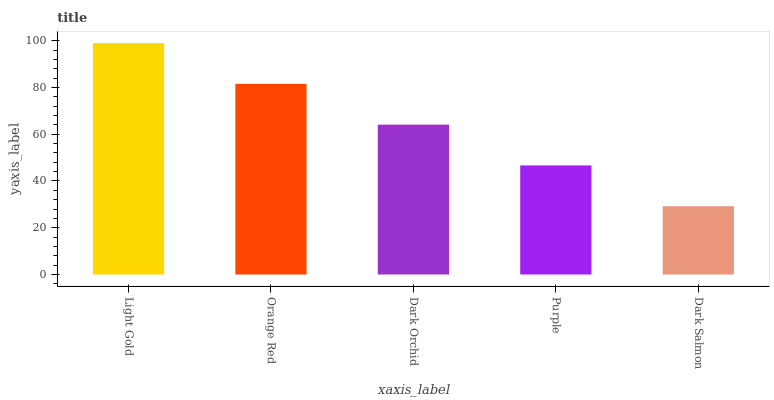Is Dark Salmon the minimum?
Answer yes or no. Yes. Is Light Gold the maximum?
Answer yes or no. Yes. Is Orange Red the minimum?
Answer yes or no. No. Is Orange Red the maximum?
Answer yes or no. No. Is Light Gold greater than Orange Red?
Answer yes or no. Yes. Is Orange Red less than Light Gold?
Answer yes or no. Yes. Is Orange Red greater than Light Gold?
Answer yes or no. No. Is Light Gold less than Orange Red?
Answer yes or no. No. Is Dark Orchid the high median?
Answer yes or no. Yes. Is Dark Orchid the low median?
Answer yes or no. Yes. Is Purple the high median?
Answer yes or no. No. Is Light Gold the low median?
Answer yes or no. No. 